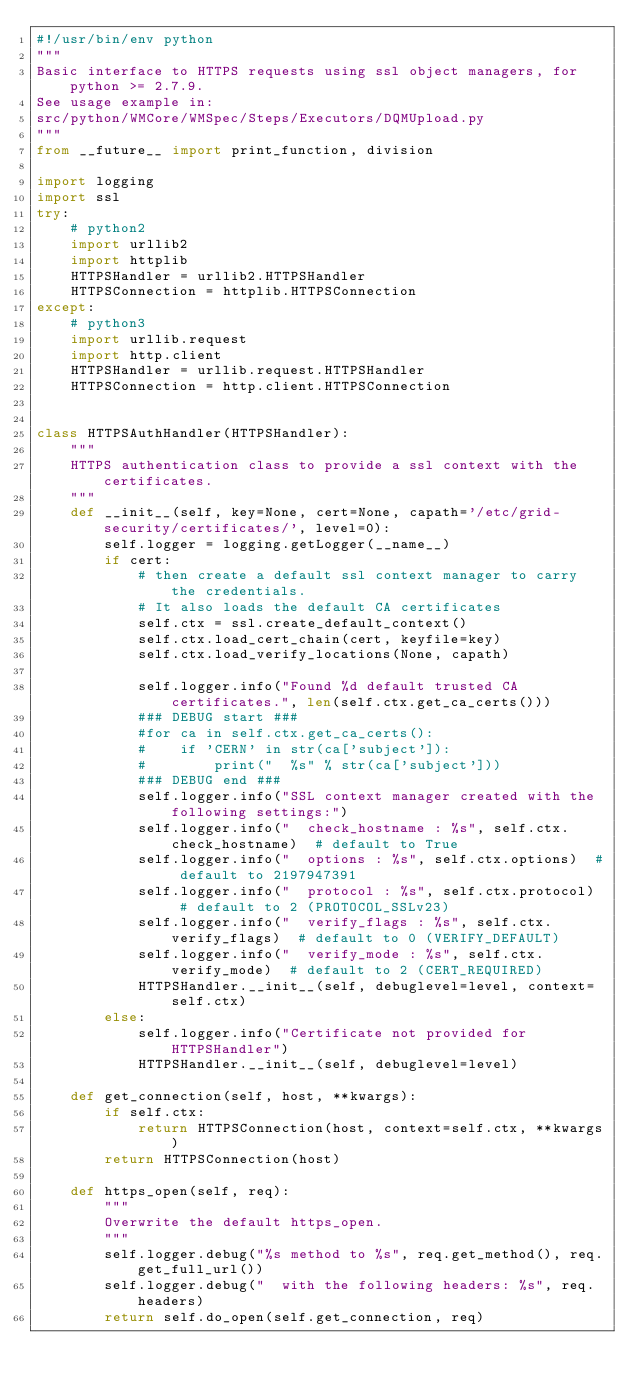Convert code to text. <code><loc_0><loc_0><loc_500><loc_500><_Python_>#!/usr/bin/env python
"""
Basic interface to HTTPS requests using ssl object managers, for python >= 2.7.9.
See usage example in:
src/python/WMCore/WMSpec/Steps/Executors/DQMUpload.py
"""
from __future__ import print_function, division

import logging
import ssl
try:
    # python2
    import urllib2
    import httplib
    HTTPSHandler = urllib2.HTTPSHandler
    HTTPSConnection = httplib.HTTPSConnection
except:
    # python3
    import urllib.request
    import http.client
    HTTPSHandler = urllib.request.HTTPSHandler
    HTTPSConnection = http.client.HTTPSConnection


class HTTPSAuthHandler(HTTPSHandler):
    """
    HTTPS authentication class to provide a ssl context with the certificates.
    """
    def __init__(self, key=None, cert=None, capath='/etc/grid-security/certificates/', level=0):
        self.logger = logging.getLogger(__name__)
        if cert:
            # then create a default ssl context manager to carry the credentials.
            # It also loads the default CA certificates
            self.ctx = ssl.create_default_context()
            self.ctx.load_cert_chain(cert, keyfile=key)
            self.ctx.load_verify_locations(None, capath)

            self.logger.info("Found %d default trusted CA certificates.", len(self.ctx.get_ca_certs()))
            ### DEBUG start ###
            #for ca in self.ctx.get_ca_certs():
            #    if 'CERN' in str(ca['subject']):
            #        print("  %s" % str(ca['subject']))
            ### DEBUG end ###
            self.logger.info("SSL context manager created with the following settings:")
            self.logger.info("  check_hostname : %s", self.ctx.check_hostname)  # default to True
            self.logger.info("  options : %s", self.ctx.options)  # default to 2197947391
            self.logger.info("  protocol : %s", self.ctx.protocol)  # default to 2 (PROTOCOL_SSLv23)
            self.logger.info("  verify_flags : %s", self.ctx.verify_flags)  # default to 0 (VERIFY_DEFAULT)
            self.logger.info("  verify_mode : %s", self.ctx.verify_mode)  # default to 2 (CERT_REQUIRED)
            HTTPSHandler.__init__(self, debuglevel=level, context=self.ctx)
        else:
            self.logger.info("Certificate not provided for HTTPSHandler")
            HTTPSHandler.__init__(self, debuglevel=level)

    def get_connection(self, host, **kwargs):
        if self.ctx:
            return HTTPSConnection(host, context=self.ctx, **kwargs)
        return HTTPSConnection(host)

    def https_open(self, req):
        """
        Overwrite the default https_open.
        """
        self.logger.debug("%s method to %s", req.get_method(), req.get_full_url())
        self.logger.debug("  with the following headers: %s", req.headers)
        return self.do_open(self.get_connection, req)
</code> 